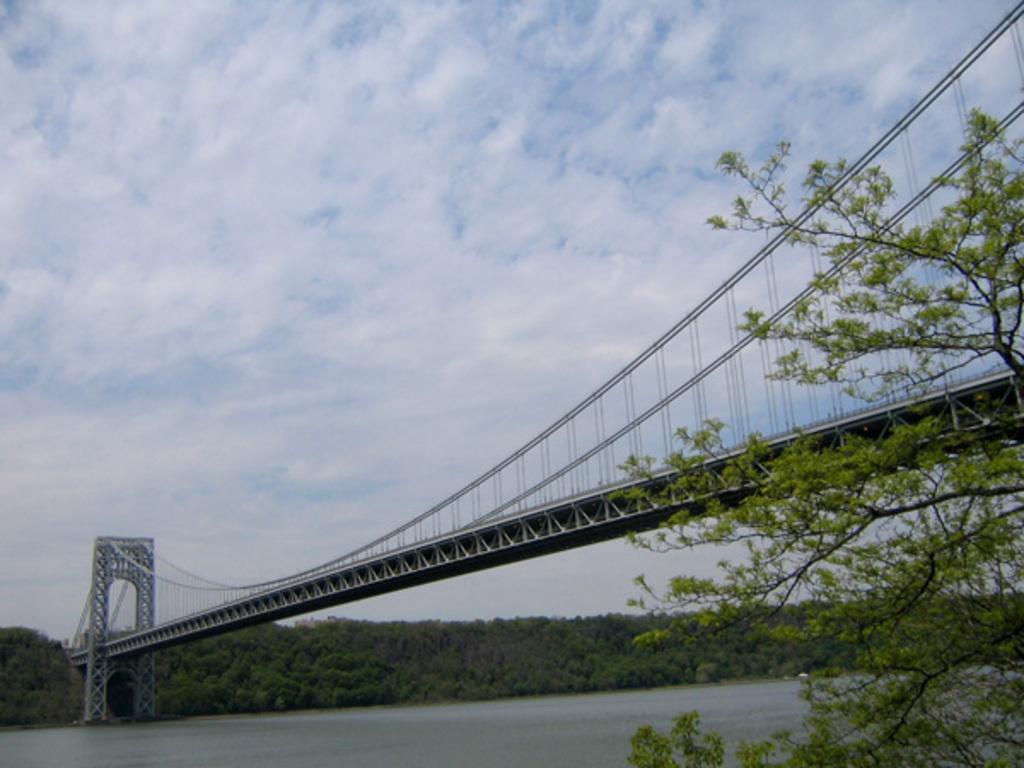In one or two sentences, can you explain what this image depicts? In this picture I can see water, bridge and trees. In the background I can see sky. 